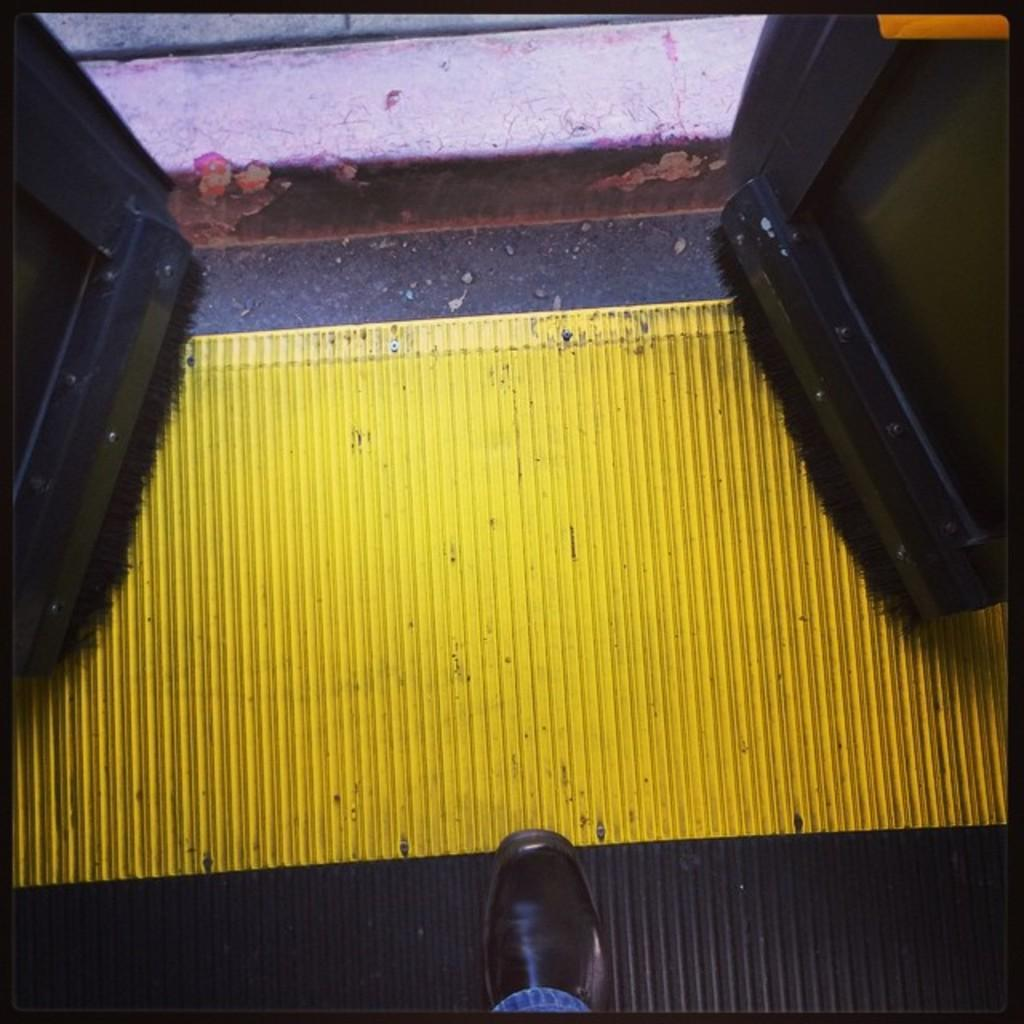What part of a person can be seen in the image? There is a person's leg visible in the image. What type of footwear is the person wearing? The person is wearing a shoe. What type of clothing is the person wearing on their leg? The person is wearing jeans. Where is the person standing in relation to the doors? The person is standing near to the doors. What color is the object that can be seen in the image? There is a yellow color object in the image. What type of potato is being used as a scarecrow in the image? There is no potato or scarecrow present in the image. 